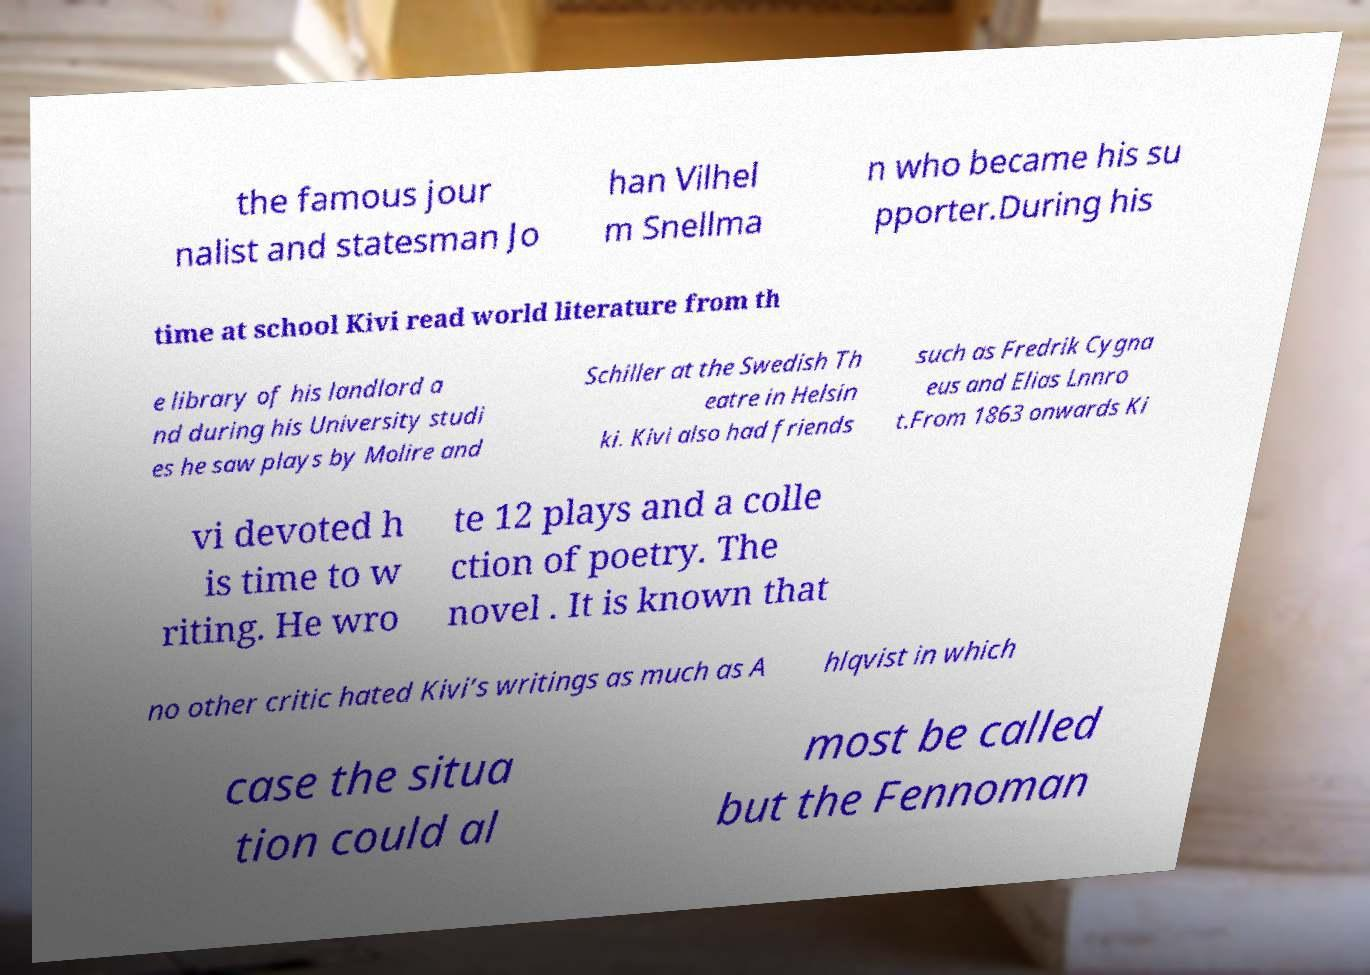What messages or text are displayed in this image? I need them in a readable, typed format. the famous jour nalist and statesman Jo han Vilhel m Snellma n who became his su pporter.During his time at school Kivi read world literature from th e library of his landlord a nd during his University studi es he saw plays by Molire and Schiller at the Swedish Th eatre in Helsin ki. Kivi also had friends such as Fredrik Cygna eus and Elias Lnnro t.From 1863 onwards Ki vi devoted h is time to w riting. He wro te 12 plays and a colle ction of poetry. The novel . It is known that no other critic hated Kivi’s writings as much as A hlqvist in which case the situa tion could al most be called but the Fennoman 